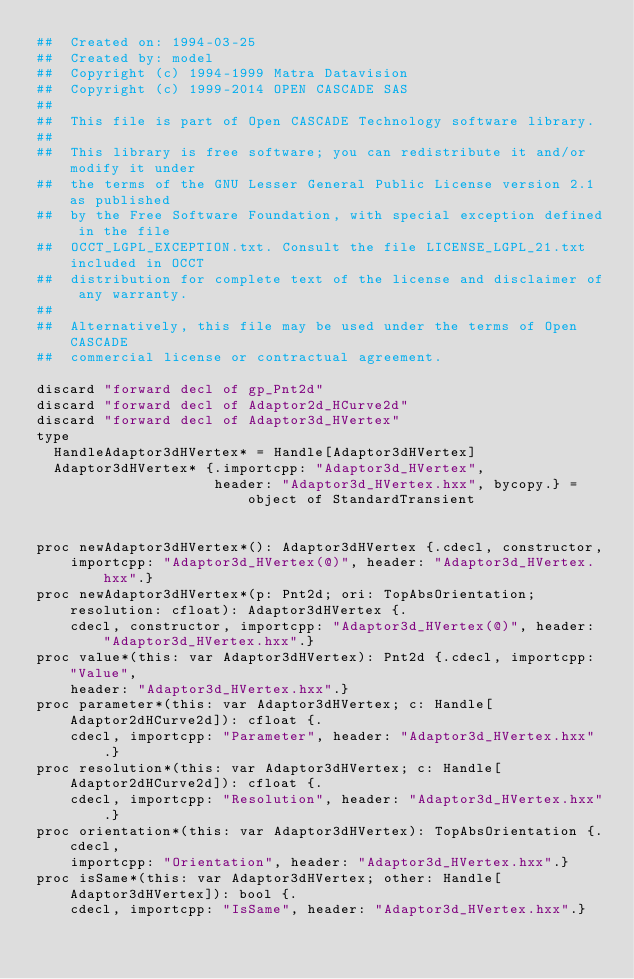Convert code to text. <code><loc_0><loc_0><loc_500><loc_500><_Nim_>##  Created on: 1994-03-25
##  Created by: model
##  Copyright (c) 1994-1999 Matra Datavision
##  Copyright (c) 1999-2014 OPEN CASCADE SAS
##
##  This file is part of Open CASCADE Technology software library.
##
##  This library is free software; you can redistribute it and/or modify it under
##  the terms of the GNU Lesser General Public License version 2.1 as published
##  by the Free Software Foundation, with special exception defined in the file
##  OCCT_LGPL_EXCEPTION.txt. Consult the file LICENSE_LGPL_21.txt included in OCCT
##  distribution for complete text of the license and disclaimer of any warranty.
##
##  Alternatively, this file may be used under the terms of Open CASCADE
##  commercial license or contractual agreement.

discard "forward decl of gp_Pnt2d"
discard "forward decl of Adaptor2d_HCurve2d"
discard "forward decl of Adaptor3d_HVertex"
type
  HandleAdaptor3dHVertex* = Handle[Adaptor3dHVertex]
  Adaptor3dHVertex* {.importcpp: "Adaptor3d_HVertex",
                     header: "Adaptor3d_HVertex.hxx", bycopy.} = object of StandardTransient


proc newAdaptor3dHVertex*(): Adaptor3dHVertex {.cdecl, constructor,
    importcpp: "Adaptor3d_HVertex(@)", header: "Adaptor3d_HVertex.hxx".}
proc newAdaptor3dHVertex*(p: Pnt2d; ori: TopAbsOrientation; resolution: cfloat): Adaptor3dHVertex {.
    cdecl, constructor, importcpp: "Adaptor3d_HVertex(@)", header: "Adaptor3d_HVertex.hxx".}
proc value*(this: var Adaptor3dHVertex): Pnt2d {.cdecl, importcpp: "Value",
    header: "Adaptor3d_HVertex.hxx".}
proc parameter*(this: var Adaptor3dHVertex; c: Handle[Adaptor2dHCurve2d]): cfloat {.
    cdecl, importcpp: "Parameter", header: "Adaptor3d_HVertex.hxx".}
proc resolution*(this: var Adaptor3dHVertex; c: Handle[Adaptor2dHCurve2d]): cfloat {.
    cdecl, importcpp: "Resolution", header: "Adaptor3d_HVertex.hxx".}
proc orientation*(this: var Adaptor3dHVertex): TopAbsOrientation {.cdecl,
    importcpp: "Orientation", header: "Adaptor3d_HVertex.hxx".}
proc isSame*(this: var Adaptor3dHVertex; other: Handle[Adaptor3dHVertex]): bool {.
    cdecl, importcpp: "IsSame", header: "Adaptor3d_HVertex.hxx".}</code> 